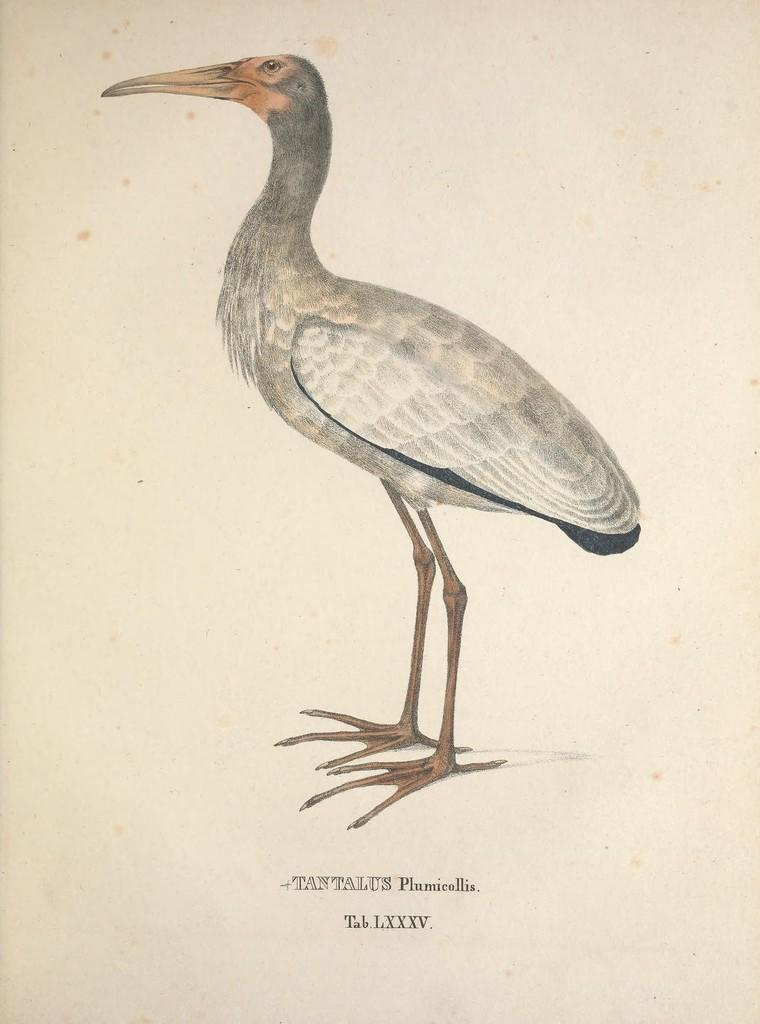What is the main subject of the picture? The main subject of the picture is a crane. What is the crane doing in the picture? The crane is standing in the picture. What color are the crane's feathers? The crane has white feathers. Is there any text in the picture? Yes, there is text written at the bottom of the page. Can you tell me how many donkeys are standing next to the crane in the image? There are no donkeys present in the image; it features a crane standing with white feathers. What type of cannon is being used by the crane in the image? There is no cannon present in the image; it features a crane with white feathers and text at the bottom of the page. 